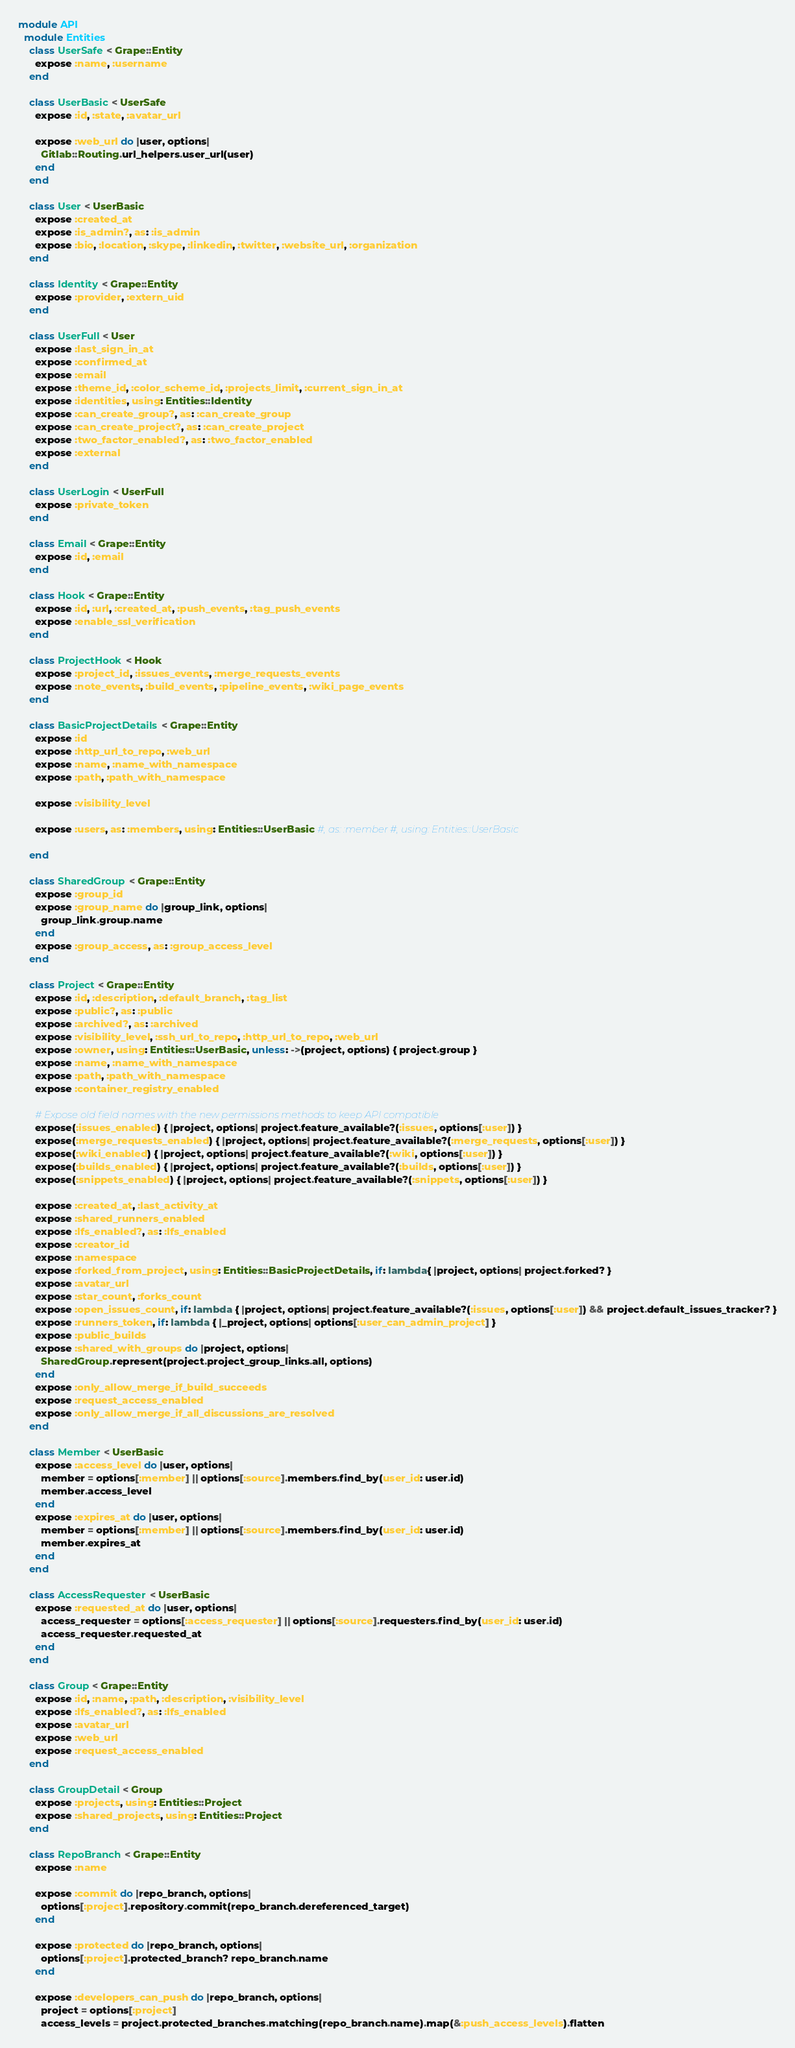<code> <loc_0><loc_0><loc_500><loc_500><_Ruby_>module API
  module Entities
    class UserSafe < Grape::Entity
      expose :name, :username
    end

    class UserBasic < UserSafe
      expose :id, :state, :avatar_url

      expose :web_url do |user, options|
        Gitlab::Routing.url_helpers.user_url(user)
      end
    end

    class User < UserBasic
      expose :created_at
      expose :is_admin?, as: :is_admin
      expose :bio, :location, :skype, :linkedin, :twitter, :website_url, :organization
    end

    class Identity < Grape::Entity
      expose :provider, :extern_uid
    end

    class UserFull < User
      expose :last_sign_in_at
      expose :confirmed_at
      expose :email
      expose :theme_id, :color_scheme_id, :projects_limit, :current_sign_in_at
      expose :identities, using: Entities::Identity
      expose :can_create_group?, as: :can_create_group
      expose :can_create_project?, as: :can_create_project
      expose :two_factor_enabled?, as: :two_factor_enabled
      expose :external
    end

    class UserLogin < UserFull
      expose :private_token
    end

    class Email < Grape::Entity
      expose :id, :email
    end

    class Hook < Grape::Entity
      expose :id, :url, :created_at, :push_events, :tag_push_events
      expose :enable_ssl_verification
    end

    class ProjectHook < Hook
      expose :project_id, :issues_events, :merge_requests_events
      expose :note_events, :build_events, :pipeline_events, :wiki_page_events
    end

    class BasicProjectDetails < Grape::Entity
      expose :id
      expose :http_url_to_repo, :web_url
      expose :name, :name_with_namespace
      expose :path, :path_with_namespace

      expose :visibility_level

      expose :users, as: :members, using: Entities::UserBasic #, as: :member #, using: Entities::UserBasic

    end

    class SharedGroup < Grape::Entity
      expose :group_id
      expose :group_name do |group_link, options|
        group_link.group.name
      end
      expose :group_access, as: :group_access_level
    end

    class Project < Grape::Entity
      expose :id, :description, :default_branch, :tag_list
      expose :public?, as: :public
      expose :archived?, as: :archived
      expose :visibility_level, :ssh_url_to_repo, :http_url_to_repo, :web_url
      expose :owner, using: Entities::UserBasic, unless: ->(project, options) { project.group }
      expose :name, :name_with_namespace
      expose :path, :path_with_namespace
      expose :container_registry_enabled

      # Expose old field names with the new permissions methods to keep API compatible
      expose(:issues_enabled) { |project, options| project.feature_available?(:issues, options[:user]) }
      expose(:merge_requests_enabled) { |project, options| project.feature_available?(:merge_requests, options[:user]) }
      expose(:wiki_enabled) { |project, options| project.feature_available?(:wiki, options[:user]) }
      expose(:builds_enabled) { |project, options| project.feature_available?(:builds, options[:user]) }
      expose(:snippets_enabled) { |project, options| project.feature_available?(:snippets, options[:user]) }

      expose :created_at, :last_activity_at
      expose :shared_runners_enabled
      expose :lfs_enabled?, as: :lfs_enabled
      expose :creator_id
      expose :namespace
      expose :forked_from_project, using: Entities::BasicProjectDetails, if: lambda{ |project, options| project.forked? }
      expose :avatar_url
      expose :star_count, :forks_count
      expose :open_issues_count, if: lambda { |project, options| project.feature_available?(:issues, options[:user]) && project.default_issues_tracker? }
      expose :runners_token, if: lambda { |_project, options| options[:user_can_admin_project] }
      expose :public_builds
      expose :shared_with_groups do |project, options|
        SharedGroup.represent(project.project_group_links.all, options)
      end
      expose :only_allow_merge_if_build_succeeds
      expose :request_access_enabled
      expose :only_allow_merge_if_all_discussions_are_resolved
    end

    class Member < UserBasic
      expose :access_level do |user, options|
        member = options[:member] || options[:source].members.find_by(user_id: user.id)
        member.access_level
      end
      expose :expires_at do |user, options|
        member = options[:member] || options[:source].members.find_by(user_id: user.id)
        member.expires_at
      end
    end

    class AccessRequester < UserBasic
      expose :requested_at do |user, options|
        access_requester = options[:access_requester] || options[:source].requesters.find_by(user_id: user.id)
        access_requester.requested_at
      end
    end

    class Group < Grape::Entity
      expose :id, :name, :path, :description, :visibility_level
      expose :lfs_enabled?, as: :lfs_enabled
      expose :avatar_url
      expose :web_url
      expose :request_access_enabled
    end

    class GroupDetail < Group
      expose :projects, using: Entities::Project
      expose :shared_projects, using: Entities::Project
    end

    class RepoBranch < Grape::Entity
      expose :name

      expose :commit do |repo_branch, options|
        options[:project].repository.commit(repo_branch.dereferenced_target)
      end

      expose :protected do |repo_branch, options|
        options[:project].protected_branch? repo_branch.name
      end

      expose :developers_can_push do |repo_branch, options|
        project = options[:project]
        access_levels = project.protected_branches.matching(repo_branch.name).map(&:push_access_levels).flatten</code> 